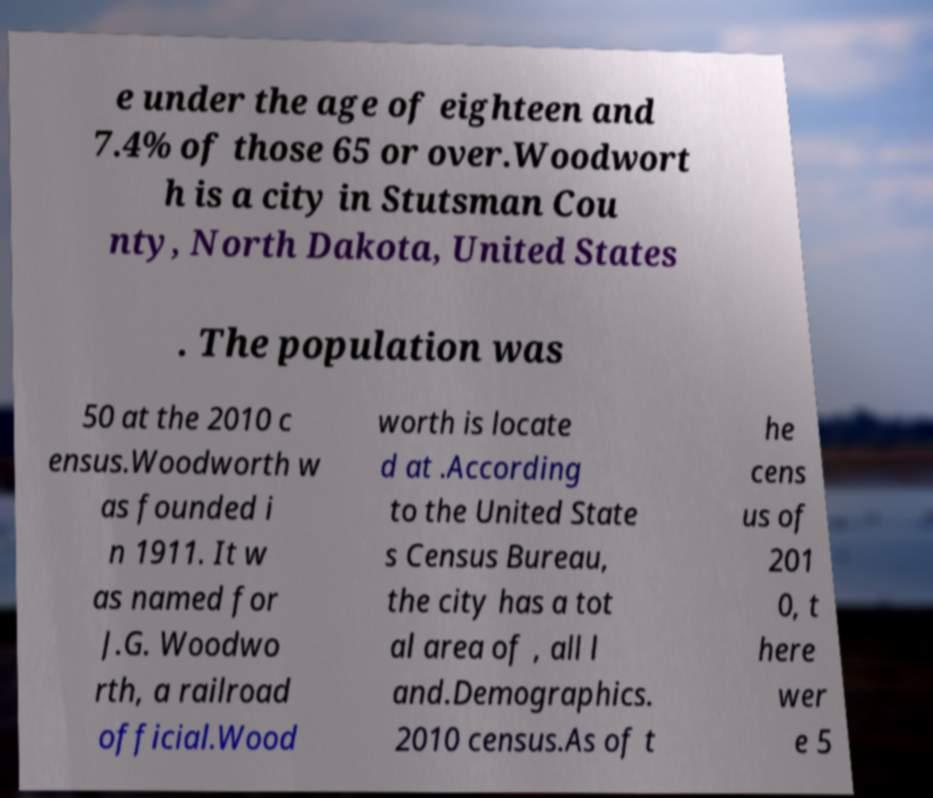For documentation purposes, I need the text within this image transcribed. Could you provide that? e under the age of eighteen and 7.4% of those 65 or over.Woodwort h is a city in Stutsman Cou nty, North Dakota, United States . The population was 50 at the 2010 c ensus.Woodworth w as founded i n 1911. It w as named for J.G. Woodwo rth, a railroad official.Wood worth is locate d at .According to the United State s Census Bureau, the city has a tot al area of , all l and.Demographics. 2010 census.As of t he cens us of 201 0, t here wer e 5 